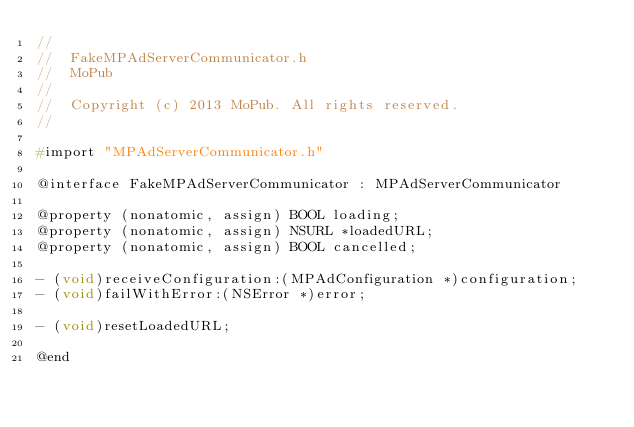<code> <loc_0><loc_0><loc_500><loc_500><_C_>//
//  FakeMPAdServerCommunicator.h
//  MoPub
//
//  Copyright (c) 2013 MoPub. All rights reserved.
//

#import "MPAdServerCommunicator.h"

@interface FakeMPAdServerCommunicator : MPAdServerCommunicator

@property (nonatomic, assign) BOOL loading;
@property (nonatomic, assign) NSURL *loadedURL;
@property (nonatomic, assign) BOOL cancelled;

- (void)receiveConfiguration:(MPAdConfiguration *)configuration;
- (void)failWithError:(NSError *)error;

- (void)resetLoadedURL;

@end
</code> 